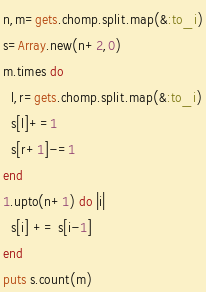<code> <loc_0><loc_0><loc_500><loc_500><_Ruby_>n,m=gets.chomp.split.map(&:to_i)
s=Array.new(n+2,0)
m.times do
  l,r=gets.chomp.split.map(&:to_i)
  s[l]+=1
  s[r+1]-=1
end
1.upto(n+1) do |i|
  s[i] += s[i-1]
end 
puts s.count(m)
</code> 